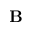<formula> <loc_0><loc_0><loc_500><loc_500>\mathbf B</formula> 